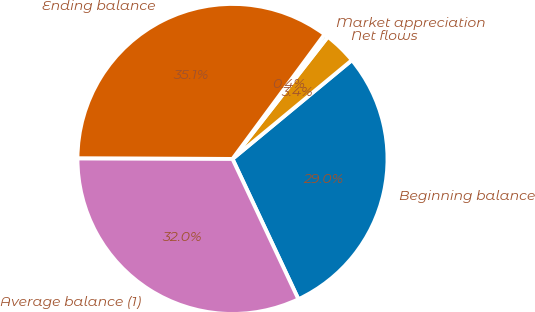<chart> <loc_0><loc_0><loc_500><loc_500><pie_chart><fcel>Beginning balance<fcel>Net flows<fcel>Market appreciation<fcel>Ending balance<fcel>Average balance (1)<nl><fcel>29.01%<fcel>3.45%<fcel>0.42%<fcel>35.08%<fcel>32.04%<nl></chart> 